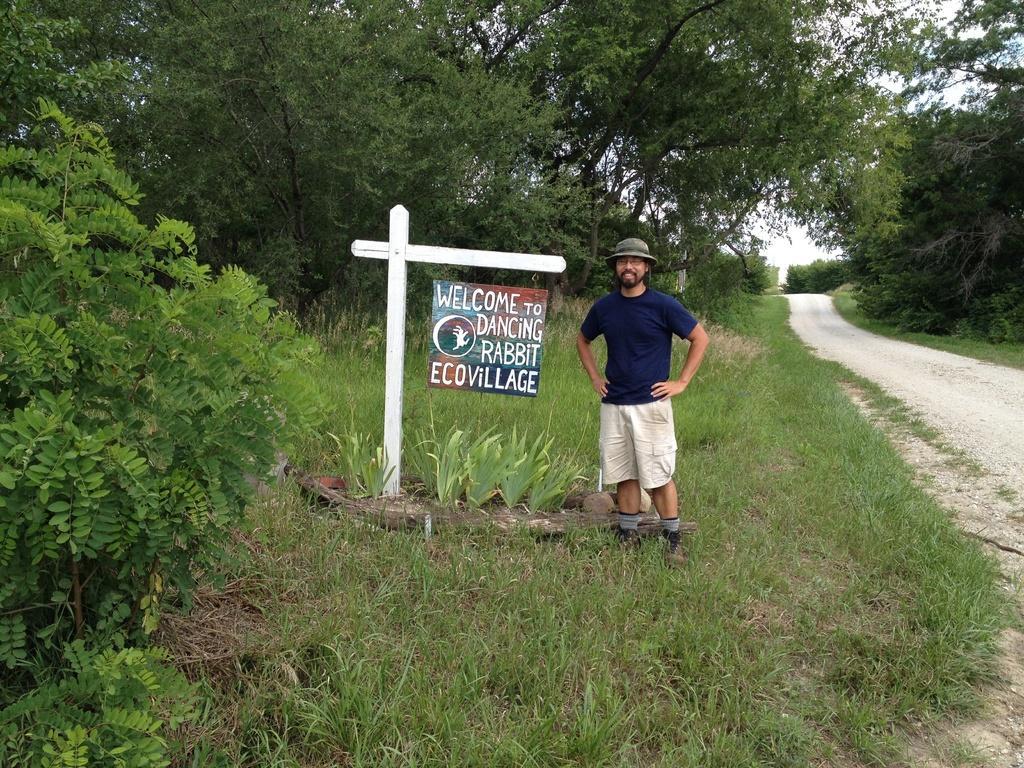Please provide a concise description of this image. In this picture I can see a man standing and he's wearing a cap on his head. I can see few trees, plants and a board with some text to the wooden pole. I can see grass on the ground and a cloudy sky. 